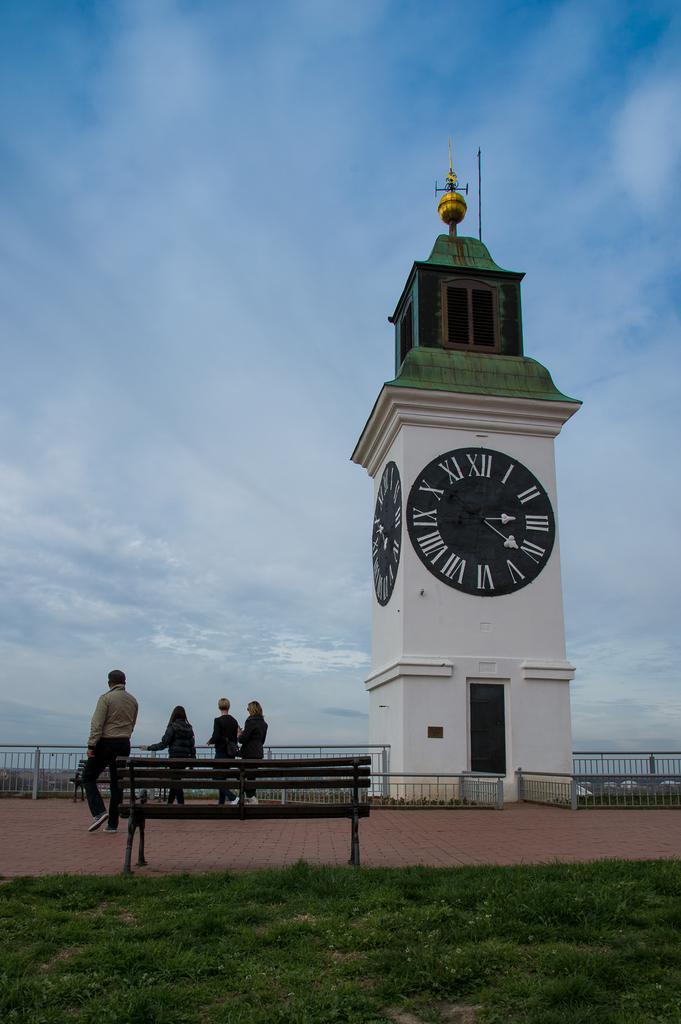Could you give a brief overview of what you see in this image? In the foreground I can see grass, bench, four persons are standing near the fence and a clock tower. In the background I can see the blue sky. This image is taken may be during a day. 